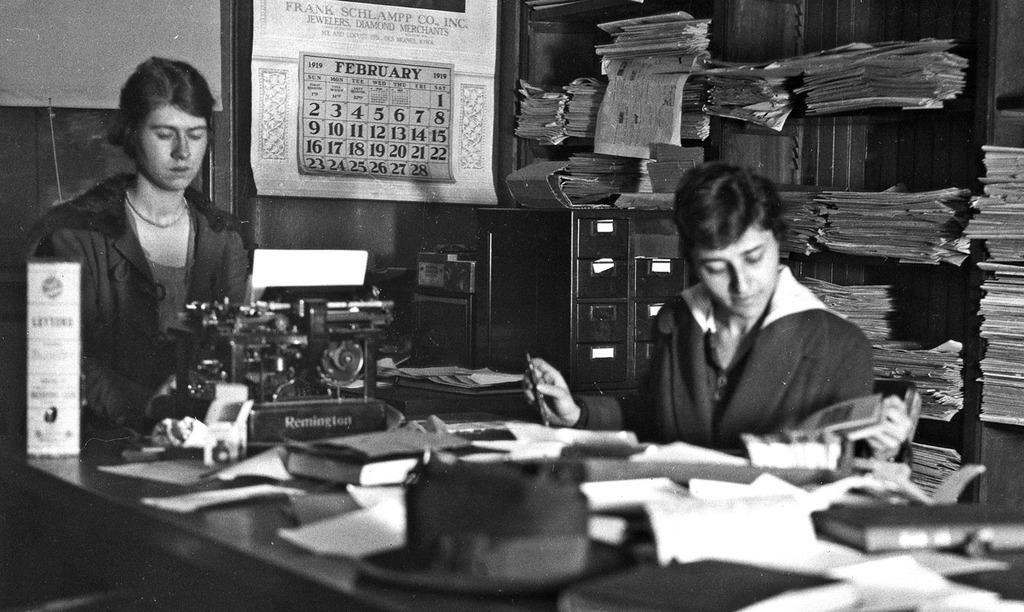What can be seen on the wall in the image? There is a poster on the wall in the image. What else is present on the wall besides the poster? There are no other objects visible on the wall in the image. What are the two people sitting on in the image? The two people are sitting on chairs in the image. What is on the table in the image? There are books and papers on the table in the image. What type of equipment is present in the image? There is an electrical equipment in the image. What type of feast is being prepared on the table in the image? There is no feast being prepared on the table in the image; it contains books and papers. Is there a jail visible in the image? There is no jail present in the image. 